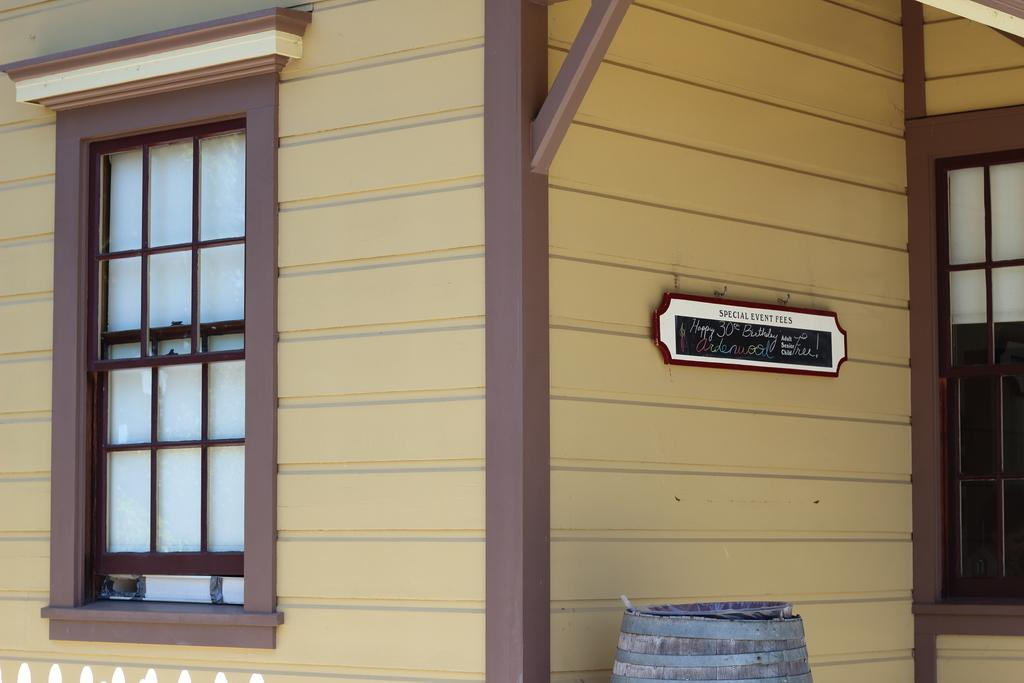What type of structure is in the picture? There is a house in the picture. Where is the window located on the house? The window is on the left side of the house. What is on the right side of the house? There is a board on the right side of the house. What can be read on the board? There is text on the board. What object is at the bottom of the image? There is a barrel at the bottom of the image. How many people are laughing in the group near the house? There is no group of people laughing near the house in the image. 